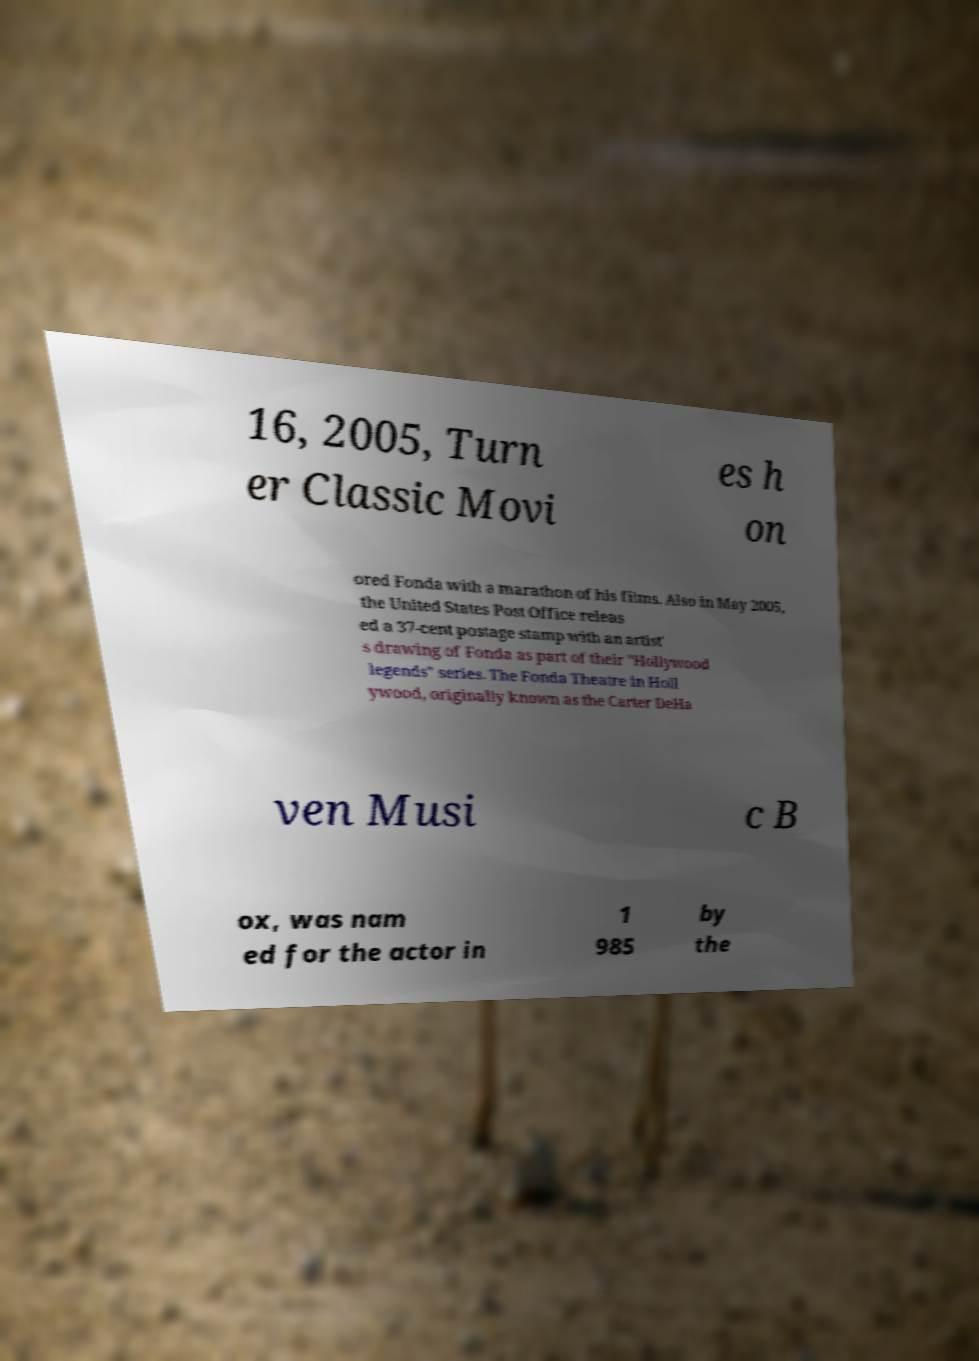I need the written content from this picture converted into text. Can you do that? 16, 2005, Turn er Classic Movi es h on ored Fonda with a marathon of his films. Also in May 2005, the United States Post Office releas ed a 37-cent postage stamp with an artist' s drawing of Fonda as part of their "Hollywood legends" series. The Fonda Theatre in Holl ywood, originally known as the Carter DeHa ven Musi c B ox, was nam ed for the actor in 1 985 by the 